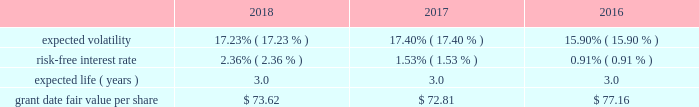Condition are valued using a monte carlo model .
Expected volatility is based on historical volatilities of traded common stock of the company and comparative companies using daily stock prices over the past three years .
The expected term is three years and the risk-free interest rate is based on the three-year u.s .
Treasury rate in effect as of the measurement date .
The table provides the weighted average assumptions used in the monte carlo simulation and the weighted average grant date fair values of psus granted for the years ended december 31: .
The grant date fair value of psus that vest ratably and have market and/or performance conditions are amortized through expense over the requisite service period using the graded-vesting method .
If dividends are paid with respect to shares of the company 2019s common stock before the rsus and psus are distributed , the company credits a liability for the value of the dividends that would have been paid if the rsus and psus were shares of company common stock .
When the rsus and psus are distributed , the company pays the participant a lump sum cash payment equal to the value of the dividend equivalents accrued .
The company accrued dividend equivalents totaling $ 1 million , less than $ 1 million and $ 1 million to accumulated deficit in the accompanying consolidated statements of changes in shareholders 2019 equity for the years ended december 31 , 2018 , 2017 and 2016 , respectively .
Employee stock purchase plan the company maintains a nonqualified employee stock purchase plan ( the 201cespp 201d ) through which employee participants may use payroll deductions to acquire company common stock at a discount .
Prior to february 5 , 2019 , the purchase price of common stock acquired under the espp was the lesser of 90% ( 90 % ) of the fair market value of the common stock at either the beginning or the end of a three -month purchase period .
On july 27 , 2018 , the espp was amended , effective february 5 , 2019 , to permit employee participants to acquire company common stock at 85% ( 85 % ) of the fair market value of the common stock at the end of the purchase period .
As of december 31 , 2018 , there were 1.9 million shares of common stock reserved for issuance under the espp .
The espp is considered compensatory .
During the years ended december 31 , 2018 , 2017 and 2016 , the company issued 95 thousand , 93 thousand and 93 thousand shares , respectively , under the espp. .
What was the purchase price of common stock acquired under the espp in 2018? 
Computations: (90% * 73.62)
Answer: 66.258. 